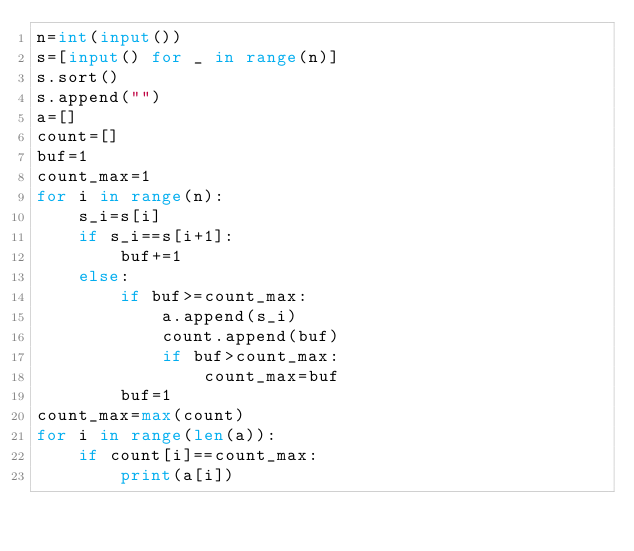Convert code to text. <code><loc_0><loc_0><loc_500><loc_500><_Python_>n=int(input())
s=[input() for _ in range(n)]
s.sort()
s.append("")
a=[]
count=[]
buf=1
count_max=1
for i in range(n):
    s_i=s[i]
    if s_i==s[i+1]:
        buf+=1
    else:
        if buf>=count_max:
            a.append(s_i)
            count.append(buf)
            if buf>count_max:
                count_max=buf
        buf=1
count_max=max(count)
for i in range(len(a)):
    if count[i]==count_max:
        print(a[i])</code> 